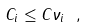<formula> <loc_0><loc_0><loc_500><loc_500>C _ { i } \leq C \nu _ { i } \ ,</formula> 